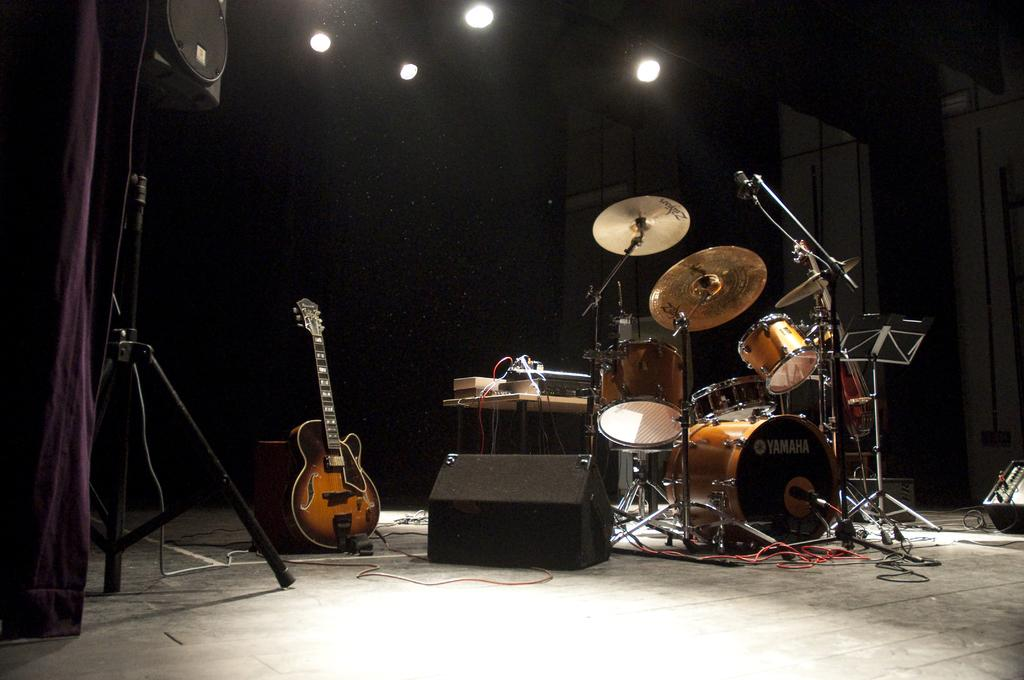What type of space is depicted in the image? There is a room in the image. What can be found inside the room? The room contains musical instruments. What is the source of light in the room? There are lights over the top of the room. What else can be seen in the image? Cables are visible in the image. How many servants are present in the image? There are no servants present in the image. What type of railway can be seen in the image? There is no railway present in the image. 